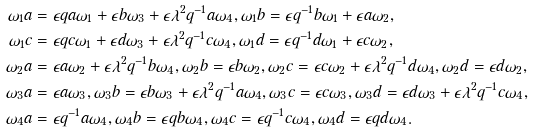<formula> <loc_0><loc_0><loc_500><loc_500>\omega _ { 1 } a & = \epsilon q a \omega _ { 1 } + \epsilon b \omega _ { 3 } + \epsilon \lambda ^ { 2 } q ^ { - 1 } a \omega _ { 4 } , \omega _ { 1 } b = \epsilon q ^ { - 1 } b \omega _ { 1 } + \epsilon a \omega _ { 2 } , \\ \omega _ { 1 } c & = \epsilon q c \omega _ { 1 } + \epsilon d \omega _ { 3 } + \epsilon \lambda ^ { 2 } q ^ { - 1 } c \omega _ { 4 } , \omega _ { 1 } d = \epsilon q ^ { - 1 } d \omega _ { 1 } + \epsilon c \omega _ { 2 } , \\ \omega _ { 2 } a & = \epsilon a \omega _ { 2 } + \epsilon \lambda ^ { 2 } q ^ { - 1 } b \omega _ { 4 } , \omega _ { 2 } b = \epsilon b \omega _ { 2 } , \omega _ { 2 } c = \epsilon c \omega _ { 2 } + \epsilon \lambda ^ { 2 } q ^ { - 1 } d \omega _ { 4 } , \omega _ { 2 } d = \epsilon d \omega _ { 2 } , \\ \omega _ { 3 } a & = \epsilon a \omega _ { 3 } , \omega _ { 3 } b = \epsilon b \omega _ { 3 } + \epsilon \lambda ^ { 2 } q ^ { - 1 } a \omega _ { 4 } , \omega _ { 3 } c = \epsilon c \omega _ { 3 } , \omega _ { 3 } d = \epsilon d \omega _ { 3 } + \epsilon \lambda ^ { 2 } q ^ { - 1 } c \omega _ { 4 } , \\ \omega _ { 4 } a & = \epsilon q ^ { - 1 } a \omega _ { 4 } , \omega _ { 4 } b = \epsilon q b \omega _ { 4 } , \omega _ { 4 } c = \epsilon q ^ { - 1 } c \omega _ { 4 } , \omega _ { 4 } d = \epsilon q d \omega _ { 4 } .</formula> 